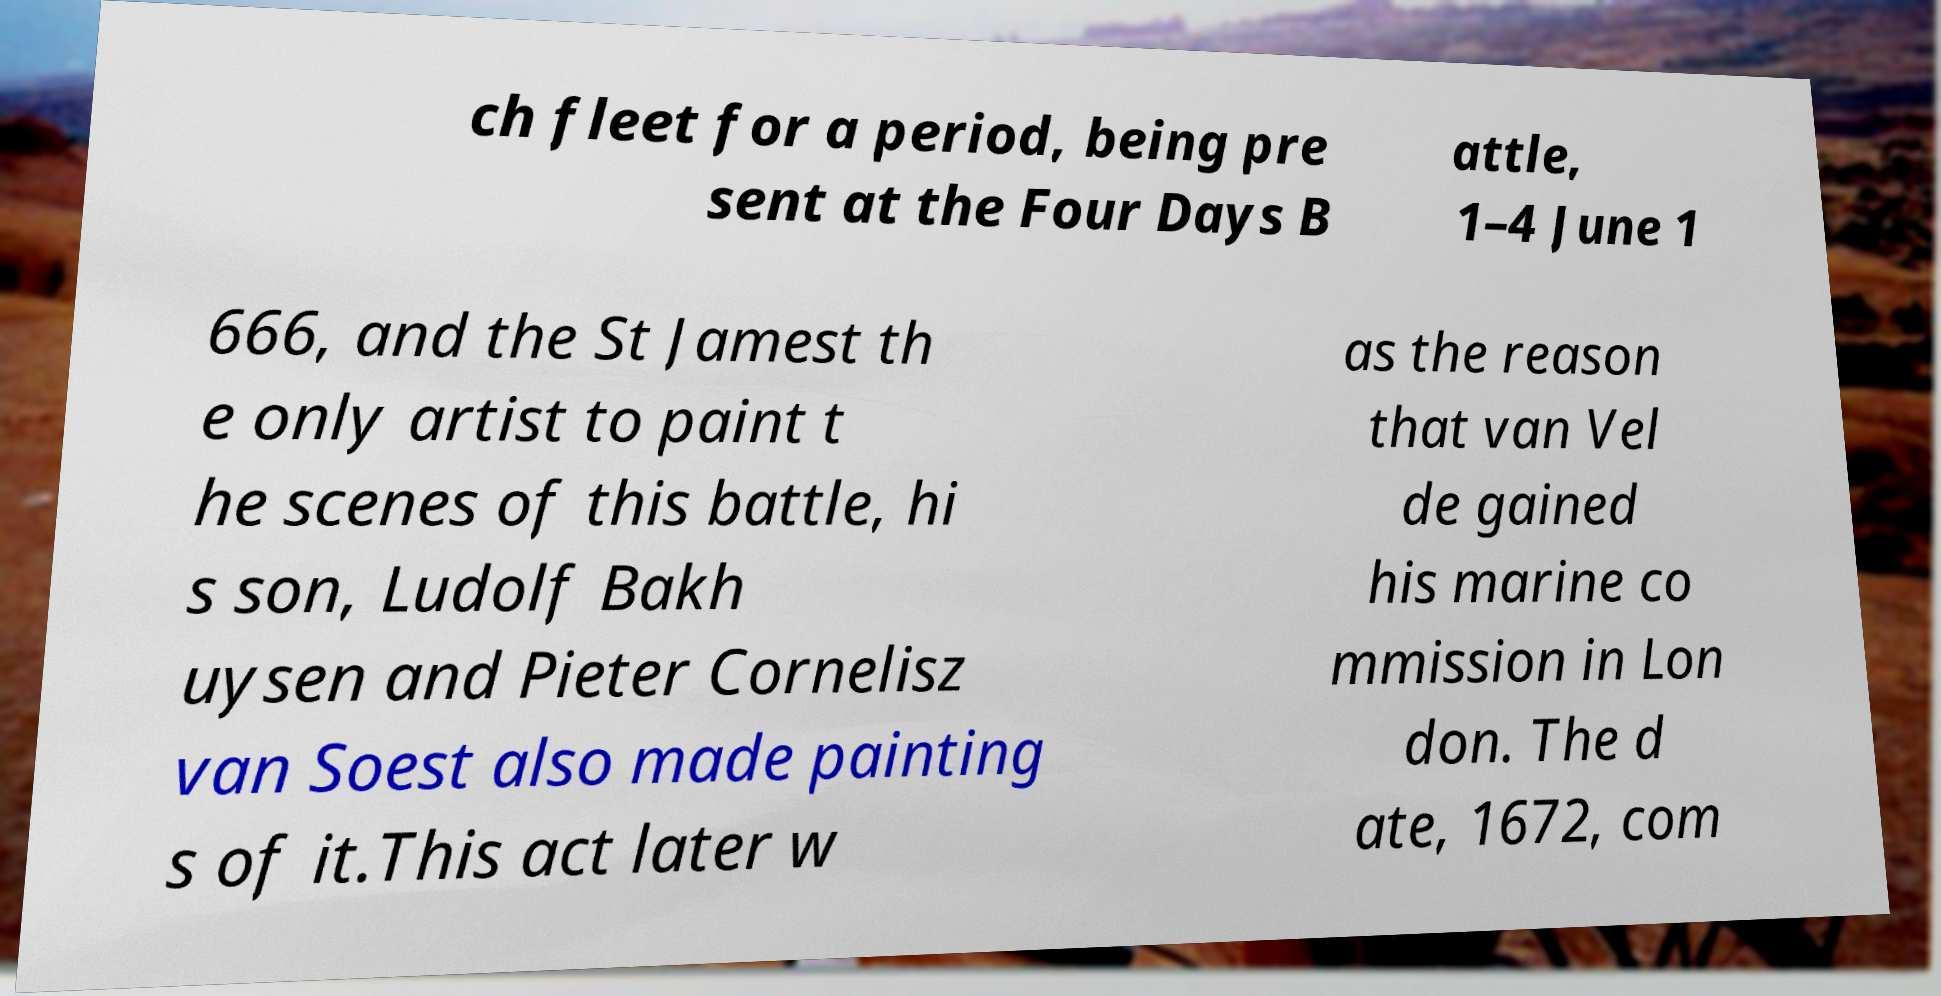Please read and relay the text visible in this image. What does it say? ch fleet for a period, being pre sent at the Four Days B attle, 1–4 June 1 666, and the St Jamest th e only artist to paint t he scenes of this battle, hi s son, Ludolf Bakh uysen and Pieter Cornelisz van Soest also made painting s of it.This act later w as the reason that van Vel de gained his marine co mmission in Lon don. The d ate, 1672, com 